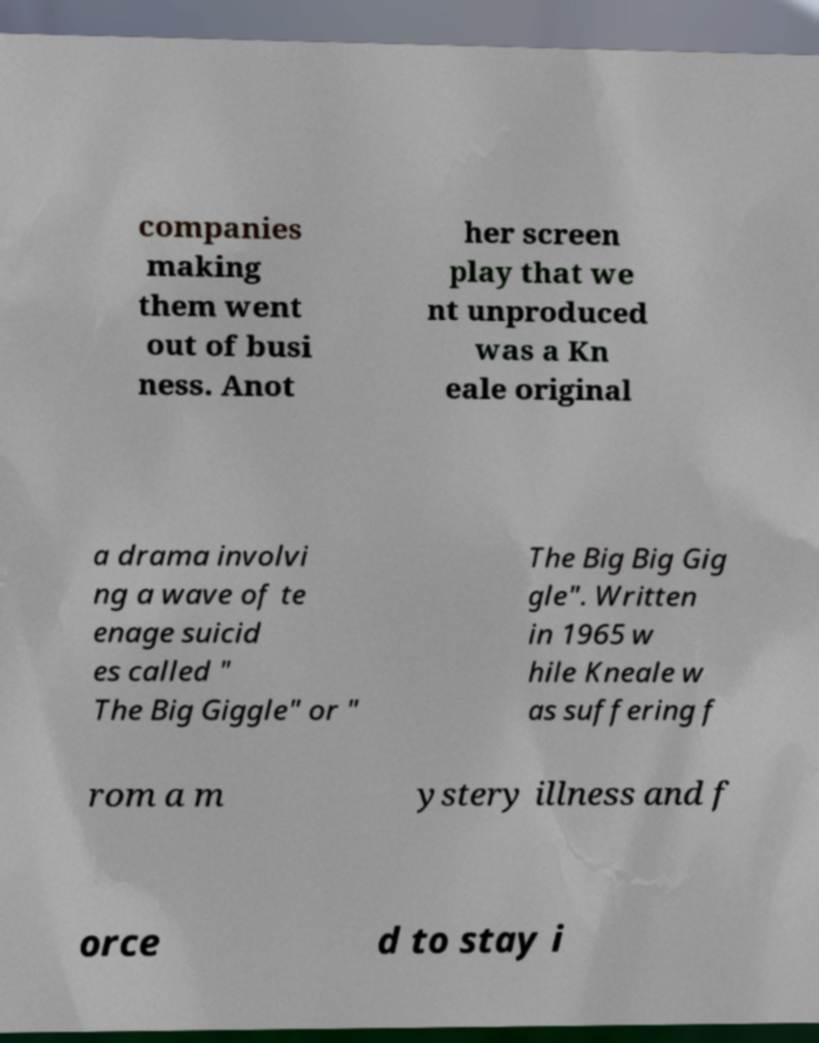Could you assist in decoding the text presented in this image and type it out clearly? companies making them went out of busi ness. Anot her screen play that we nt unproduced was a Kn eale original a drama involvi ng a wave of te enage suicid es called " The Big Giggle" or " The Big Big Gig gle". Written in 1965 w hile Kneale w as suffering f rom a m ystery illness and f orce d to stay i 